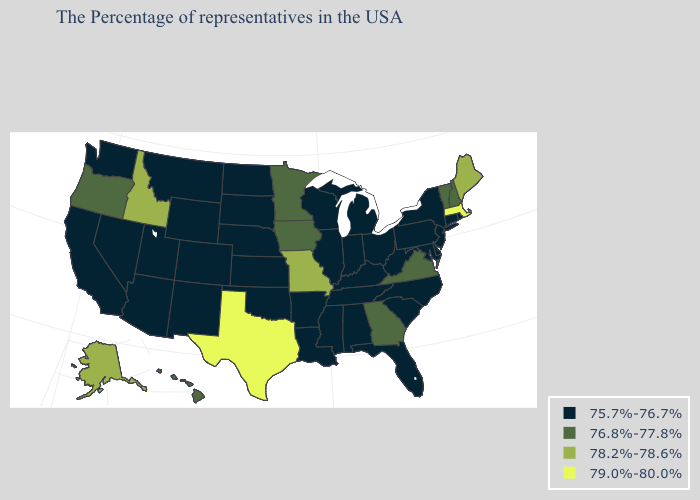What is the highest value in the USA?
Give a very brief answer. 79.0%-80.0%. What is the value of Florida?
Give a very brief answer. 75.7%-76.7%. What is the value of Iowa?
Concise answer only. 76.8%-77.8%. Among the states that border Oregon , which have the lowest value?
Be succinct. Nevada, California, Washington. What is the lowest value in the USA?
Give a very brief answer. 75.7%-76.7%. Which states have the lowest value in the USA?
Quick response, please. Rhode Island, Connecticut, New York, New Jersey, Delaware, Maryland, Pennsylvania, North Carolina, South Carolina, West Virginia, Ohio, Florida, Michigan, Kentucky, Indiana, Alabama, Tennessee, Wisconsin, Illinois, Mississippi, Louisiana, Arkansas, Kansas, Nebraska, Oklahoma, South Dakota, North Dakota, Wyoming, Colorado, New Mexico, Utah, Montana, Arizona, Nevada, California, Washington. Among the states that border Oregon , does Idaho have the lowest value?
Answer briefly. No. Does the map have missing data?
Give a very brief answer. No. Which states have the lowest value in the USA?
Quick response, please. Rhode Island, Connecticut, New York, New Jersey, Delaware, Maryland, Pennsylvania, North Carolina, South Carolina, West Virginia, Ohio, Florida, Michigan, Kentucky, Indiana, Alabama, Tennessee, Wisconsin, Illinois, Mississippi, Louisiana, Arkansas, Kansas, Nebraska, Oklahoma, South Dakota, North Dakota, Wyoming, Colorado, New Mexico, Utah, Montana, Arizona, Nevada, California, Washington. Does South Carolina have the highest value in the USA?
Keep it brief. No. Name the states that have a value in the range 79.0%-80.0%?
Give a very brief answer. Massachusetts, Texas. What is the lowest value in the Northeast?
Concise answer only. 75.7%-76.7%. Name the states that have a value in the range 75.7%-76.7%?
Be succinct. Rhode Island, Connecticut, New York, New Jersey, Delaware, Maryland, Pennsylvania, North Carolina, South Carolina, West Virginia, Ohio, Florida, Michigan, Kentucky, Indiana, Alabama, Tennessee, Wisconsin, Illinois, Mississippi, Louisiana, Arkansas, Kansas, Nebraska, Oklahoma, South Dakota, North Dakota, Wyoming, Colorado, New Mexico, Utah, Montana, Arizona, Nevada, California, Washington. What is the highest value in states that border Maryland?
Concise answer only. 76.8%-77.8%. What is the value of South Carolina?
Short answer required. 75.7%-76.7%. 